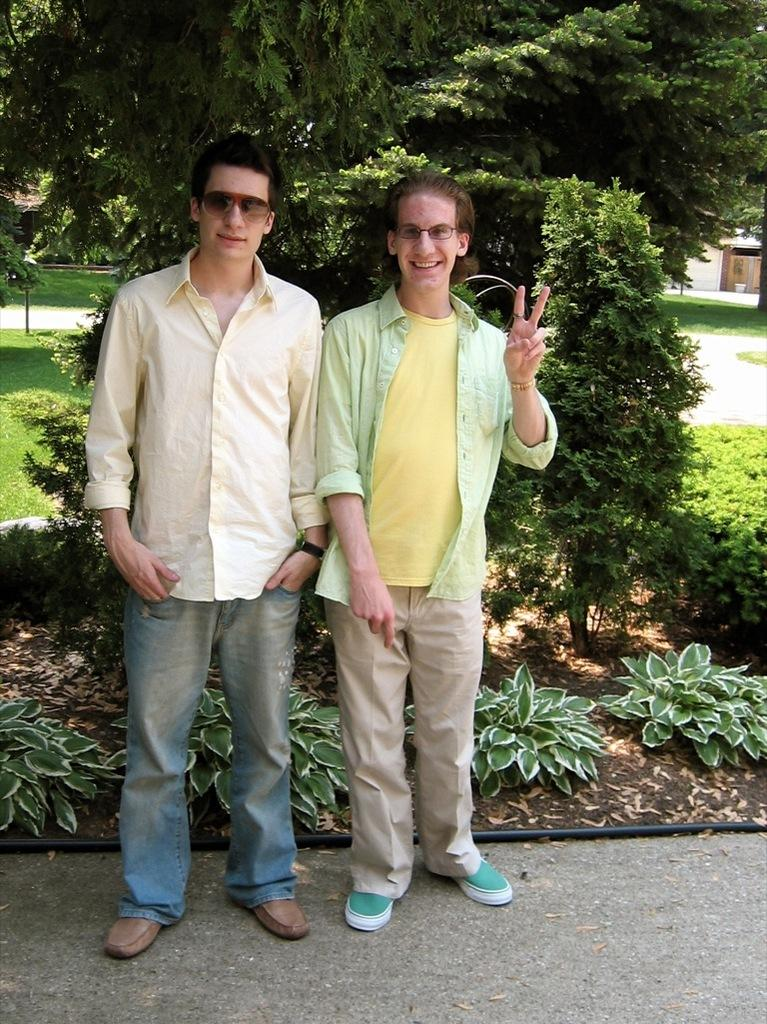How many people are in the image? There are two men standing in the image. What is the surface they are standing on? The men are standing on land. What can be seen in the background of the image? There are trees, plants, and grass in the background of the image. What type of trousers is the boy wearing in the image? There is no boy present in the image, only two men. What is the source of pleasure in the image? The image does not depict any specific source of pleasure; it simply shows two men standing on land with a background of trees, plants, and grass. 